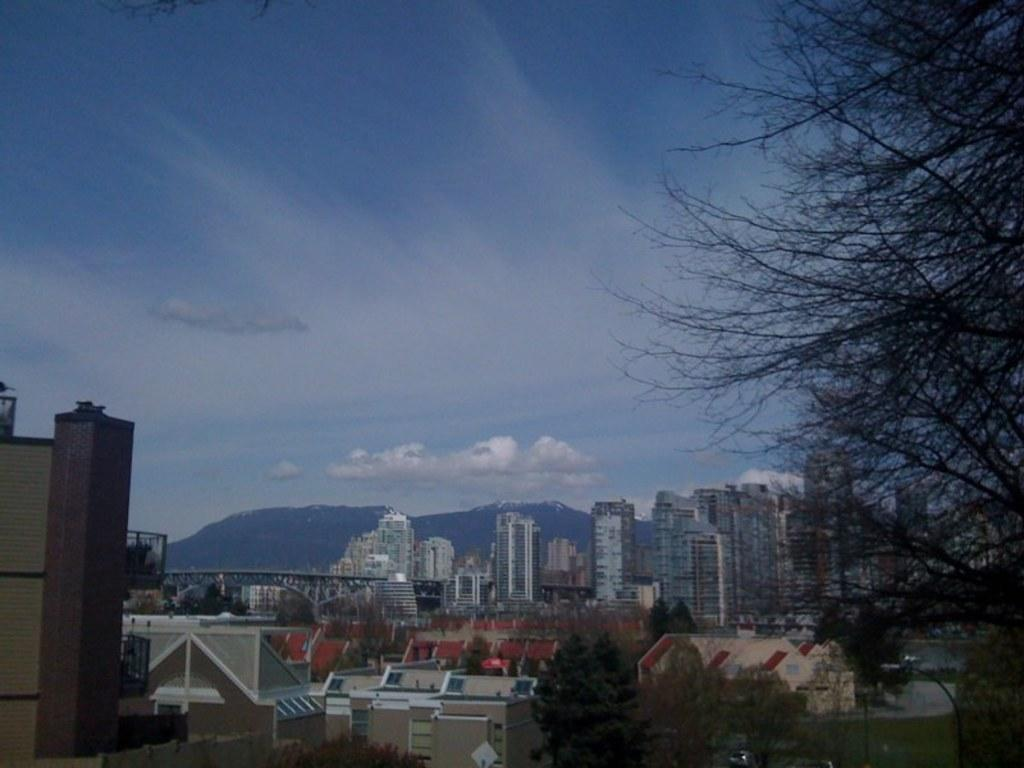What type of structures can be seen in the image? There are buildings in the image. What other natural elements are present in the image? There are trees in the image. What can be seen in the distance in the background of the image? There are mountains visible in the background of the image. What is visible above the buildings and trees in the image? The sky is visible in the background of the image. What is your uncle's thought about the hot weather in the image? There is no reference to an uncle or hot weather in the image, so it is not possible to answer that question. 